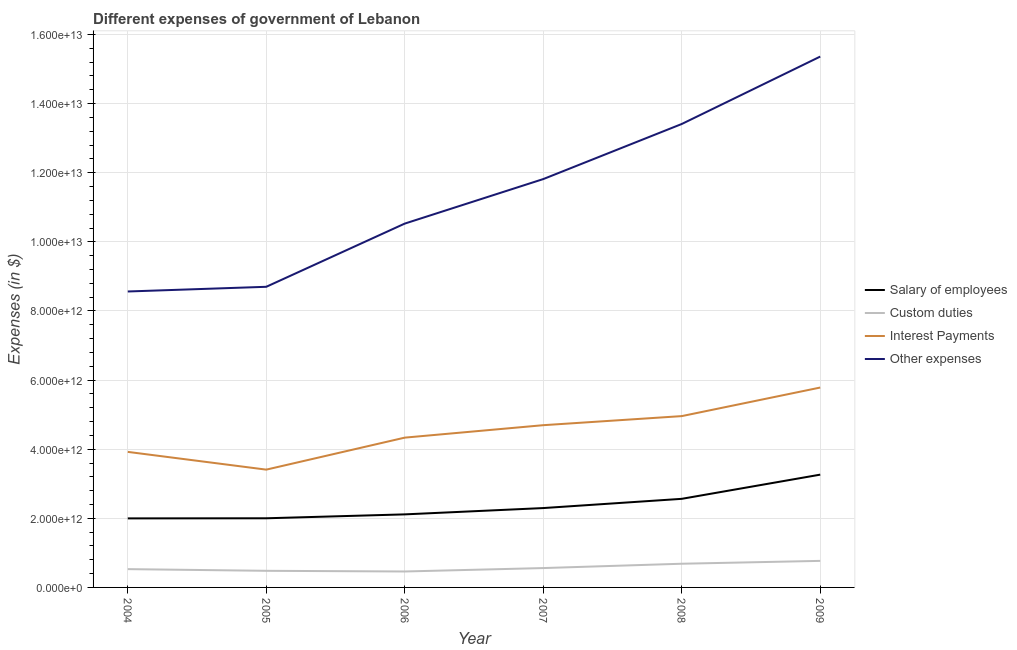Does the line corresponding to amount spent on interest payments intersect with the line corresponding to amount spent on custom duties?
Make the answer very short. No. Is the number of lines equal to the number of legend labels?
Your answer should be very brief. Yes. What is the amount spent on salary of employees in 2006?
Your answer should be very brief. 2.11e+12. Across all years, what is the maximum amount spent on custom duties?
Make the answer very short. 7.68e+11. Across all years, what is the minimum amount spent on custom duties?
Offer a very short reply. 4.61e+11. In which year was the amount spent on custom duties maximum?
Your answer should be compact. 2009. What is the total amount spent on interest payments in the graph?
Make the answer very short. 2.71e+13. What is the difference between the amount spent on custom duties in 2005 and that in 2009?
Offer a terse response. -2.87e+11. What is the difference between the amount spent on salary of employees in 2006 and the amount spent on other expenses in 2008?
Offer a terse response. -1.13e+13. What is the average amount spent on salary of employees per year?
Your answer should be very brief. 2.37e+12. In the year 2005, what is the difference between the amount spent on other expenses and amount spent on interest payments?
Make the answer very short. 5.29e+12. In how many years, is the amount spent on salary of employees greater than 14000000000000 $?
Your response must be concise. 0. What is the ratio of the amount spent on other expenses in 2005 to that in 2009?
Provide a succinct answer. 0.57. Is the difference between the amount spent on other expenses in 2007 and 2008 greater than the difference between the amount spent on interest payments in 2007 and 2008?
Your response must be concise. No. What is the difference between the highest and the second highest amount spent on other expenses?
Give a very brief answer. 1.95e+12. What is the difference between the highest and the lowest amount spent on other expenses?
Ensure brevity in your answer.  6.80e+12. Is the amount spent on salary of employees strictly greater than the amount spent on interest payments over the years?
Ensure brevity in your answer.  No. Is the amount spent on other expenses strictly less than the amount spent on salary of employees over the years?
Your answer should be compact. No. How many years are there in the graph?
Offer a terse response. 6. What is the difference between two consecutive major ticks on the Y-axis?
Make the answer very short. 2.00e+12. Does the graph contain any zero values?
Make the answer very short. No. Does the graph contain grids?
Ensure brevity in your answer.  Yes. Where does the legend appear in the graph?
Offer a very short reply. Center right. How are the legend labels stacked?
Your answer should be very brief. Vertical. What is the title of the graph?
Your answer should be compact. Different expenses of government of Lebanon. What is the label or title of the Y-axis?
Your answer should be very brief. Expenses (in $). What is the Expenses (in $) of Salary of employees in 2004?
Offer a very short reply. 2.00e+12. What is the Expenses (in $) in Custom duties in 2004?
Give a very brief answer. 5.30e+11. What is the Expenses (in $) of Interest Payments in 2004?
Your answer should be compact. 3.92e+12. What is the Expenses (in $) of Other expenses in 2004?
Make the answer very short. 8.56e+12. What is the Expenses (in $) in Salary of employees in 2005?
Offer a terse response. 2.00e+12. What is the Expenses (in $) of Custom duties in 2005?
Your response must be concise. 4.81e+11. What is the Expenses (in $) in Interest Payments in 2005?
Offer a very short reply. 3.41e+12. What is the Expenses (in $) in Other expenses in 2005?
Ensure brevity in your answer.  8.70e+12. What is the Expenses (in $) in Salary of employees in 2006?
Ensure brevity in your answer.  2.11e+12. What is the Expenses (in $) in Custom duties in 2006?
Keep it short and to the point. 4.61e+11. What is the Expenses (in $) of Interest Payments in 2006?
Your response must be concise. 4.33e+12. What is the Expenses (in $) of Other expenses in 2006?
Provide a short and direct response. 1.05e+13. What is the Expenses (in $) in Salary of employees in 2007?
Provide a succinct answer. 2.30e+12. What is the Expenses (in $) of Custom duties in 2007?
Your answer should be very brief. 5.61e+11. What is the Expenses (in $) in Interest Payments in 2007?
Provide a short and direct response. 4.69e+12. What is the Expenses (in $) of Other expenses in 2007?
Keep it short and to the point. 1.18e+13. What is the Expenses (in $) in Salary of employees in 2008?
Offer a very short reply. 2.56e+12. What is the Expenses (in $) of Custom duties in 2008?
Offer a very short reply. 6.86e+11. What is the Expenses (in $) of Interest Payments in 2008?
Ensure brevity in your answer.  4.96e+12. What is the Expenses (in $) in Other expenses in 2008?
Keep it short and to the point. 1.34e+13. What is the Expenses (in $) of Salary of employees in 2009?
Your answer should be compact. 3.26e+12. What is the Expenses (in $) of Custom duties in 2009?
Provide a succinct answer. 7.68e+11. What is the Expenses (in $) of Interest Payments in 2009?
Make the answer very short. 5.78e+12. What is the Expenses (in $) of Other expenses in 2009?
Ensure brevity in your answer.  1.54e+13. Across all years, what is the maximum Expenses (in $) in Salary of employees?
Keep it short and to the point. 3.26e+12. Across all years, what is the maximum Expenses (in $) of Custom duties?
Keep it short and to the point. 7.68e+11. Across all years, what is the maximum Expenses (in $) in Interest Payments?
Provide a succinct answer. 5.78e+12. Across all years, what is the maximum Expenses (in $) of Other expenses?
Give a very brief answer. 1.54e+13. Across all years, what is the minimum Expenses (in $) of Salary of employees?
Provide a succinct answer. 2.00e+12. Across all years, what is the minimum Expenses (in $) of Custom duties?
Provide a short and direct response. 4.61e+11. Across all years, what is the minimum Expenses (in $) in Interest Payments?
Keep it short and to the point. 3.41e+12. Across all years, what is the minimum Expenses (in $) of Other expenses?
Your answer should be very brief. 8.56e+12. What is the total Expenses (in $) of Salary of employees in the graph?
Your answer should be very brief. 1.42e+13. What is the total Expenses (in $) of Custom duties in the graph?
Offer a terse response. 3.49e+12. What is the total Expenses (in $) in Interest Payments in the graph?
Give a very brief answer. 2.71e+13. What is the total Expenses (in $) in Other expenses in the graph?
Your response must be concise. 6.84e+13. What is the difference between the Expenses (in $) of Salary of employees in 2004 and that in 2005?
Offer a very short reply. -3.43e+09. What is the difference between the Expenses (in $) in Custom duties in 2004 and that in 2005?
Your response must be concise. 4.86e+1. What is the difference between the Expenses (in $) of Interest Payments in 2004 and that in 2005?
Make the answer very short. 5.13e+11. What is the difference between the Expenses (in $) in Other expenses in 2004 and that in 2005?
Offer a terse response. -1.36e+11. What is the difference between the Expenses (in $) of Salary of employees in 2004 and that in 2006?
Provide a short and direct response. -1.16e+11. What is the difference between the Expenses (in $) of Custom duties in 2004 and that in 2006?
Ensure brevity in your answer.  6.85e+1. What is the difference between the Expenses (in $) in Interest Payments in 2004 and that in 2006?
Make the answer very short. -4.12e+11. What is the difference between the Expenses (in $) of Other expenses in 2004 and that in 2006?
Give a very brief answer. -1.96e+12. What is the difference between the Expenses (in $) in Salary of employees in 2004 and that in 2007?
Your answer should be very brief. -2.99e+11. What is the difference between the Expenses (in $) in Custom duties in 2004 and that in 2007?
Provide a succinct answer. -3.09e+1. What is the difference between the Expenses (in $) in Interest Payments in 2004 and that in 2007?
Provide a succinct answer. -7.72e+11. What is the difference between the Expenses (in $) in Other expenses in 2004 and that in 2007?
Ensure brevity in your answer.  -3.25e+12. What is the difference between the Expenses (in $) in Salary of employees in 2004 and that in 2008?
Your answer should be compact. -5.66e+11. What is the difference between the Expenses (in $) of Custom duties in 2004 and that in 2008?
Offer a very short reply. -1.56e+11. What is the difference between the Expenses (in $) of Interest Payments in 2004 and that in 2008?
Offer a terse response. -1.04e+12. What is the difference between the Expenses (in $) of Other expenses in 2004 and that in 2008?
Offer a very short reply. -4.85e+12. What is the difference between the Expenses (in $) in Salary of employees in 2004 and that in 2009?
Offer a very short reply. -1.27e+12. What is the difference between the Expenses (in $) of Custom duties in 2004 and that in 2009?
Ensure brevity in your answer.  -2.39e+11. What is the difference between the Expenses (in $) in Interest Payments in 2004 and that in 2009?
Provide a succinct answer. -1.86e+12. What is the difference between the Expenses (in $) of Other expenses in 2004 and that in 2009?
Your answer should be very brief. -6.80e+12. What is the difference between the Expenses (in $) of Salary of employees in 2005 and that in 2006?
Offer a terse response. -1.13e+11. What is the difference between the Expenses (in $) in Custom duties in 2005 and that in 2006?
Your answer should be compact. 1.98e+1. What is the difference between the Expenses (in $) in Interest Payments in 2005 and that in 2006?
Give a very brief answer. -9.26e+11. What is the difference between the Expenses (in $) of Other expenses in 2005 and that in 2006?
Offer a terse response. -1.83e+12. What is the difference between the Expenses (in $) in Salary of employees in 2005 and that in 2007?
Give a very brief answer. -2.96e+11. What is the difference between the Expenses (in $) in Custom duties in 2005 and that in 2007?
Your answer should be compact. -7.96e+1. What is the difference between the Expenses (in $) of Interest Payments in 2005 and that in 2007?
Provide a succinct answer. -1.29e+12. What is the difference between the Expenses (in $) in Other expenses in 2005 and that in 2007?
Offer a terse response. -3.12e+12. What is the difference between the Expenses (in $) in Salary of employees in 2005 and that in 2008?
Give a very brief answer. -5.63e+11. What is the difference between the Expenses (in $) in Custom duties in 2005 and that in 2008?
Your response must be concise. -2.05e+11. What is the difference between the Expenses (in $) in Interest Payments in 2005 and that in 2008?
Your answer should be compact. -1.55e+12. What is the difference between the Expenses (in $) of Other expenses in 2005 and that in 2008?
Your answer should be compact. -4.71e+12. What is the difference between the Expenses (in $) of Salary of employees in 2005 and that in 2009?
Provide a succinct answer. -1.26e+12. What is the difference between the Expenses (in $) in Custom duties in 2005 and that in 2009?
Give a very brief answer. -2.87e+11. What is the difference between the Expenses (in $) in Interest Payments in 2005 and that in 2009?
Provide a short and direct response. -2.38e+12. What is the difference between the Expenses (in $) in Other expenses in 2005 and that in 2009?
Your response must be concise. -6.66e+12. What is the difference between the Expenses (in $) of Salary of employees in 2006 and that in 2007?
Your response must be concise. -1.83e+11. What is the difference between the Expenses (in $) in Custom duties in 2006 and that in 2007?
Ensure brevity in your answer.  -9.94e+1. What is the difference between the Expenses (in $) in Interest Payments in 2006 and that in 2007?
Offer a very short reply. -3.60e+11. What is the difference between the Expenses (in $) in Other expenses in 2006 and that in 2007?
Offer a very short reply. -1.29e+12. What is the difference between the Expenses (in $) in Salary of employees in 2006 and that in 2008?
Your answer should be very brief. -4.50e+11. What is the difference between the Expenses (in $) in Custom duties in 2006 and that in 2008?
Offer a terse response. -2.25e+11. What is the difference between the Expenses (in $) in Interest Payments in 2006 and that in 2008?
Ensure brevity in your answer.  -6.23e+11. What is the difference between the Expenses (in $) of Other expenses in 2006 and that in 2008?
Give a very brief answer. -2.88e+12. What is the difference between the Expenses (in $) in Salary of employees in 2006 and that in 2009?
Your response must be concise. -1.15e+12. What is the difference between the Expenses (in $) of Custom duties in 2006 and that in 2009?
Keep it short and to the point. -3.07e+11. What is the difference between the Expenses (in $) in Interest Payments in 2006 and that in 2009?
Keep it short and to the point. -1.45e+12. What is the difference between the Expenses (in $) of Other expenses in 2006 and that in 2009?
Offer a very short reply. -4.83e+12. What is the difference between the Expenses (in $) in Salary of employees in 2007 and that in 2008?
Your response must be concise. -2.67e+11. What is the difference between the Expenses (in $) in Custom duties in 2007 and that in 2008?
Provide a short and direct response. -1.25e+11. What is the difference between the Expenses (in $) of Interest Payments in 2007 and that in 2008?
Ensure brevity in your answer.  -2.63e+11. What is the difference between the Expenses (in $) in Other expenses in 2007 and that in 2008?
Offer a terse response. -1.59e+12. What is the difference between the Expenses (in $) of Salary of employees in 2007 and that in 2009?
Keep it short and to the point. -9.67e+11. What is the difference between the Expenses (in $) of Custom duties in 2007 and that in 2009?
Give a very brief answer. -2.08e+11. What is the difference between the Expenses (in $) of Interest Payments in 2007 and that in 2009?
Give a very brief answer. -1.09e+12. What is the difference between the Expenses (in $) in Other expenses in 2007 and that in 2009?
Your response must be concise. -3.55e+12. What is the difference between the Expenses (in $) of Salary of employees in 2008 and that in 2009?
Provide a short and direct response. -7.00e+11. What is the difference between the Expenses (in $) of Custom duties in 2008 and that in 2009?
Give a very brief answer. -8.26e+1. What is the difference between the Expenses (in $) of Interest Payments in 2008 and that in 2009?
Ensure brevity in your answer.  -8.27e+11. What is the difference between the Expenses (in $) of Other expenses in 2008 and that in 2009?
Keep it short and to the point. -1.95e+12. What is the difference between the Expenses (in $) of Salary of employees in 2004 and the Expenses (in $) of Custom duties in 2005?
Provide a short and direct response. 1.52e+12. What is the difference between the Expenses (in $) in Salary of employees in 2004 and the Expenses (in $) in Interest Payments in 2005?
Ensure brevity in your answer.  -1.41e+12. What is the difference between the Expenses (in $) of Salary of employees in 2004 and the Expenses (in $) of Other expenses in 2005?
Offer a very short reply. -6.70e+12. What is the difference between the Expenses (in $) in Custom duties in 2004 and the Expenses (in $) in Interest Payments in 2005?
Make the answer very short. -2.88e+12. What is the difference between the Expenses (in $) in Custom duties in 2004 and the Expenses (in $) in Other expenses in 2005?
Your response must be concise. -8.17e+12. What is the difference between the Expenses (in $) of Interest Payments in 2004 and the Expenses (in $) of Other expenses in 2005?
Offer a very short reply. -4.78e+12. What is the difference between the Expenses (in $) in Salary of employees in 2004 and the Expenses (in $) in Custom duties in 2006?
Offer a terse response. 1.54e+12. What is the difference between the Expenses (in $) of Salary of employees in 2004 and the Expenses (in $) of Interest Payments in 2006?
Provide a succinct answer. -2.34e+12. What is the difference between the Expenses (in $) of Salary of employees in 2004 and the Expenses (in $) of Other expenses in 2006?
Keep it short and to the point. -8.53e+12. What is the difference between the Expenses (in $) of Custom duties in 2004 and the Expenses (in $) of Interest Payments in 2006?
Your answer should be very brief. -3.80e+12. What is the difference between the Expenses (in $) of Custom duties in 2004 and the Expenses (in $) of Other expenses in 2006?
Provide a short and direct response. -1.00e+13. What is the difference between the Expenses (in $) in Interest Payments in 2004 and the Expenses (in $) in Other expenses in 2006?
Your response must be concise. -6.61e+12. What is the difference between the Expenses (in $) in Salary of employees in 2004 and the Expenses (in $) in Custom duties in 2007?
Your answer should be compact. 1.44e+12. What is the difference between the Expenses (in $) of Salary of employees in 2004 and the Expenses (in $) of Interest Payments in 2007?
Provide a short and direct response. -2.70e+12. What is the difference between the Expenses (in $) in Salary of employees in 2004 and the Expenses (in $) in Other expenses in 2007?
Ensure brevity in your answer.  -9.82e+12. What is the difference between the Expenses (in $) of Custom duties in 2004 and the Expenses (in $) of Interest Payments in 2007?
Ensure brevity in your answer.  -4.16e+12. What is the difference between the Expenses (in $) of Custom duties in 2004 and the Expenses (in $) of Other expenses in 2007?
Your response must be concise. -1.13e+13. What is the difference between the Expenses (in $) of Interest Payments in 2004 and the Expenses (in $) of Other expenses in 2007?
Ensure brevity in your answer.  -7.89e+12. What is the difference between the Expenses (in $) of Salary of employees in 2004 and the Expenses (in $) of Custom duties in 2008?
Your response must be concise. 1.31e+12. What is the difference between the Expenses (in $) in Salary of employees in 2004 and the Expenses (in $) in Interest Payments in 2008?
Ensure brevity in your answer.  -2.96e+12. What is the difference between the Expenses (in $) in Salary of employees in 2004 and the Expenses (in $) in Other expenses in 2008?
Provide a short and direct response. -1.14e+13. What is the difference between the Expenses (in $) in Custom duties in 2004 and the Expenses (in $) in Interest Payments in 2008?
Provide a short and direct response. -4.43e+12. What is the difference between the Expenses (in $) of Custom duties in 2004 and the Expenses (in $) of Other expenses in 2008?
Your answer should be very brief. -1.29e+13. What is the difference between the Expenses (in $) of Interest Payments in 2004 and the Expenses (in $) of Other expenses in 2008?
Keep it short and to the point. -9.49e+12. What is the difference between the Expenses (in $) in Salary of employees in 2004 and the Expenses (in $) in Custom duties in 2009?
Your answer should be very brief. 1.23e+12. What is the difference between the Expenses (in $) of Salary of employees in 2004 and the Expenses (in $) of Interest Payments in 2009?
Your answer should be compact. -3.79e+12. What is the difference between the Expenses (in $) of Salary of employees in 2004 and the Expenses (in $) of Other expenses in 2009?
Offer a very short reply. -1.34e+13. What is the difference between the Expenses (in $) of Custom duties in 2004 and the Expenses (in $) of Interest Payments in 2009?
Offer a terse response. -5.25e+12. What is the difference between the Expenses (in $) of Custom duties in 2004 and the Expenses (in $) of Other expenses in 2009?
Your answer should be compact. -1.48e+13. What is the difference between the Expenses (in $) of Interest Payments in 2004 and the Expenses (in $) of Other expenses in 2009?
Your answer should be compact. -1.14e+13. What is the difference between the Expenses (in $) of Salary of employees in 2005 and the Expenses (in $) of Custom duties in 2006?
Your answer should be compact. 1.54e+12. What is the difference between the Expenses (in $) of Salary of employees in 2005 and the Expenses (in $) of Interest Payments in 2006?
Your answer should be very brief. -2.33e+12. What is the difference between the Expenses (in $) in Salary of employees in 2005 and the Expenses (in $) in Other expenses in 2006?
Offer a very short reply. -8.53e+12. What is the difference between the Expenses (in $) in Custom duties in 2005 and the Expenses (in $) in Interest Payments in 2006?
Provide a succinct answer. -3.85e+12. What is the difference between the Expenses (in $) in Custom duties in 2005 and the Expenses (in $) in Other expenses in 2006?
Your answer should be compact. -1.00e+13. What is the difference between the Expenses (in $) of Interest Payments in 2005 and the Expenses (in $) of Other expenses in 2006?
Provide a short and direct response. -7.12e+12. What is the difference between the Expenses (in $) in Salary of employees in 2005 and the Expenses (in $) in Custom duties in 2007?
Keep it short and to the point. 1.44e+12. What is the difference between the Expenses (in $) in Salary of employees in 2005 and the Expenses (in $) in Interest Payments in 2007?
Keep it short and to the point. -2.69e+12. What is the difference between the Expenses (in $) of Salary of employees in 2005 and the Expenses (in $) of Other expenses in 2007?
Make the answer very short. -9.82e+12. What is the difference between the Expenses (in $) in Custom duties in 2005 and the Expenses (in $) in Interest Payments in 2007?
Keep it short and to the point. -4.21e+12. What is the difference between the Expenses (in $) in Custom duties in 2005 and the Expenses (in $) in Other expenses in 2007?
Give a very brief answer. -1.13e+13. What is the difference between the Expenses (in $) of Interest Payments in 2005 and the Expenses (in $) of Other expenses in 2007?
Ensure brevity in your answer.  -8.41e+12. What is the difference between the Expenses (in $) in Salary of employees in 2005 and the Expenses (in $) in Custom duties in 2008?
Your response must be concise. 1.32e+12. What is the difference between the Expenses (in $) in Salary of employees in 2005 and the Expenses (in $) in Interest Payments in 2008?
Offer a very short reply. -2.96e+12. What is the difference between the Expenses (in $) of Salary of employees in 2005 and the Expenses (in $) of Other expenses in 2008?
Keep it short and to the point. -1.14e+13. What is the difference between the Expenses (in $) in Custom duties in 2005 and the Expenses (in $) in Interest Payments in 2008?
Ensure brevity in your answer.  -4.48e+12. What is the difference between the Expenses (in $) of Custom duties in 2005 and the Expenses (in $) of Other expenses in 2008?
Ensure brevity in your answer.  -1.29e+13. What is the difference between the Expenses (in $) in Interest Payments in 2005 and the Expenses (in $) in Other expenses in 2008?
Your response must be concise. -1.00e+13. What is the difference between the Expenses (in $) in Salary of employees in 2005 and the Expenses (in $) in Custom duties in 2009?
Your answer should be very brief. 1.23e+12. What is the difference between the Expenses (in $) of Salary of employees in 2005 and the Expenses (in $) of Interest Payments in 2009?
Make the answer very short. -3.78e+12. What is the difference between the Expenses (in $) in Salary of employees in 2005 and the Expenses (in $) in Other expenses in 2009?
Your answer should be very brief. -1.34e+13. What is the difference between the Expenses (in $) in Custom duties in 2005 and the Expenses (in $) in Interest Payments in 2009?
Keep it short and to the point. -5.30e+12. What is the difference between the Expenses (in $) in Custom duties in 2005 and the Expenses (in $) in Other expenses in 2009?
Keep it short and to the point. -1.49e+13. What is the difference between the Expenses (in $) of Interest Payments in 2005 and the Expenses (in $) of Other expenses in 2009?
Your answer should be very brief. -1.20e+13. What is the difference between the Expenses (in $) in Salary of employees in 2006 and the Expenses (in $) in Custom duties in 2007?
Offer a very short reply. 1.55e+12. What is the difference between the Expenses (in $) in Salary of employees in 2006 and the Expenses (in $) in Interest Payments in 2007?
Your answer should be compact. -2.58e+12. What is the difference between the Expenses (in $) of Salary of employees in 2006 and the Expenses (in $) of Other expenses in 2007?
Offer a very short reply. -9.70e+12. What is the difference between the Expenses (in $) of Custom duties in 2006 and the Expenses (in $) of Interest Payments in 2007?
Offer a terse response. -4.23e+12. What is the difference between the Expenses (in $) in Custom duties in 2006 and the Expenses (in $) in Other expenses in 2007?
Your answer should be very brief. -1.14e+13. What is the difference between the Expenses (in $) of Interest Payments in 2006 and the Expenses (in $) of Other expenses in 2007?
Provide a short and direct response. -7.48e+12. What is the difference between the Expenses (in $) of Salary of employees in 2006 and the Expenses (in $) of Custom duties in 2008?
Make the answer very short. 1.43e+12. What is the difference between the Expenses (in $) in Salary of employees in 2006 and the Expenses (in $) in Interest Payments in 2008?
Provide a succinct answer. -2.84e+12. What is the difference between the Expenses (in $) of Salary of employees in 2006 and the Expenses (in $) of Other expenses in 2008?
Offer a very short reply. -1.13e+13. What is the difference between the Expenses (in $) of Custom duties in 2006 and the Expenses (in $) of Interest Payments in 2008?
Provide a short and direct response. -4.50e+12. What is the difference between the Expenses (in $) in Custom duties in 2006 and the Expenses (in $) in Other expenses in 2008?
Your response must be concise. -1.29e+13. What is the difference between the Expenses (in $) in Interest Payments in 2006 and the Expenses (in $) in Other expenses in 2008?
Your answer should be very brief. -9.08e+12. What is the difference between the Expenses (in $) in Salary of employees in 2006 and the Expenses (in $) in Custom duties in 2009?
Offer a very short reply. 1.35e+12. What is the difference between the Expenses (in $) in Salary of employees in 2006 and the Expenses (in $) in Interest Payments in 2009?
Your answer should be very brief. -3.67e+12. What is the difference between the Expenses (in $) of Salary of employees in 2006 and the Expenses (in $) of Other expenses in 2009?
Your answer should be very brief. -1.32e+13. What is the difference between the Expenses (in $) in Custom duties in 2006 and the Expenses (in $) in Interest Payments in 2009?
Keep it short and to the point. -5.32e+12. What is the difference between the Expenses (in $) in Custom duties in 2006 and the Expenses (in $) in Other expenses in 2009?
Offer a terse response. -1.49e+13. What is the difference between the Expenses (in $) of Interest Payments in 2006 and the Expenses (in $) of Other expenses in 2009?
Your answer should be very brief. -1.10e+13. What is the difference between the Expenses (in $) of Salary of employees in 2007 and the Expenses (in $) of Custom duties in 2008?
Your response must be concise. 1.61e+12. What is the difference between the Expenses (in $) of Salary of employees in 2007 and the Expenses (in $) of Interest Payments in 2008?
Keep it short and to the point. -2.66e+12. What is the difference between the Expenses (in $) in Salary of employees in 2007 and the Expenses (in $) in Other expenses in 2008?
Ensure brevity in your answer.  -1.11e+13. What is the difference between the Expenses (in $) of Custom duties in 2007 and the Expenses (in $) of Interest Payments in 2008?
Provide a succinct answer. -4.40e+12. What is the difference between the Expenses (in $) of Custom duties in 2007 and the Expenses (in $) of Other expenses in 2008?
Offer a terse response. -1.28e+13. What is the difference between the Expenses (in $) in Interest Payments in 2007 and the Expenses (in $) in Other expenses in 2008?
Keep it short and to the point. -8.72e+12. What is the difference between the Expenses (in $) in Salary of employees in 2007 and the Expenses (in $) in Custom duties in 2009?
Offer a terse response. 1.53e+12. What is the difference between the Expenses (in $) of Salary of employees in 2007 and the Expenses (in $) of Interest Payments in 2009?
Provide a succinct answer. -3.49e+12. What is the difference between the Expenses (in $) in Salary of employees in 2007 and the Expenses (in $) in Other expenses in 2009?
Provide a succinct answer. -1.31e+13. What is the difference between the Expenses (in $) in Custom duties in 2007 and the Expenses (in $) in Interest Payments in 2009?
Offer a very short reply. -5.22e+12. What is the difference between the Expenses (in $) in Custom duties in 2007 and the Expenses (in $) in Other expenses in 2009?
Your answer should be very brief. -1.48e+13. What is the difference between the Expenses (in $) of Interest Payments in 2007 and the Expenses (in $) of Other expenses in 2009?
Provide a short and direct response. -1.07e+13. What is the difference between the Expenses (in $) of Salary of employees in 2008 and the Expenses (in $) of Custom duties in 2009?
Your answer should be compact. 1.80e+12. What is the difference between the Expenses (in $) of Salary of employees in 2008 and the Expenses (in $) of Interest Payments in 2009?
Your answer should be very brief. -3.22e+12. What is the difference between the Expenses (in $) in Salary of employees in 2008 and the Expenses (in $) in Other expenses in 2009?
Your answer should be very brief. -1.28e+13. What is the difference between the Expenses (in $) of Custom duties in 2008 and the Expenses (in $) of Interest Payments in 2009?
Provide a succinct answer. -5.10e+12. What is the difference between the Expenses (in $) in Custom duties in 2008 and the Expenses (in $) in Other expenses in 2009?
Provide a short and direct response. -1.47e+13. What is the difference between the Expenses (in $) in Interest Payments in 2008 and the Expenses (in $) in Other expenses in 2009?
Offer a terse response. -1.04e+13. What is the average Expenses (in $) in Salary of employees per year?
Your response must be concise. 2.37e+12. What is the average Expenses (in $) in Custom duties per year?
Your answer should be compact. 5.81e+11. What is the average Expenses (in $) in Interest Payments per year?
Keep it short and to the point. 4.52e+12. What is the average Expenses (in $) in Other expenses per year?
Offer a very short reply. 1.14e+13. In the year 2004, what is the difference between the Expenses (in $) of Salary of employees and Expenses (in $) of Custom duties?
Your answer should be compact. 1.47e+12. In the year 2004, what is the difference between the Expenses (in $) of Salary of employees and Expenses (in $) of Interest Payments?
Provide a short and direct response. -1.92e+12. In the year 2004, what is the difference between the Expenses (in $) of Salary of employees and Expenses (in $) of Other expenses?
Your answer should be compact. -6.57e+12. In the year 2004, what is the difference between the Expenses (in $) of Custom duties and Expenses (in $) of Interest Payments?
Your answer should be very brief. -3.39e+12. In the year 2004, what is the difference between the Expenses (in $) of Custom duties and Expenses (in $) of Other expenses?
Offer a terse response. -8.03e+12. In the year 2004, what is the difference between the Expenses (in $) in Interest Payments and Expenses (in $) in Other expenses?
Offer a terse response. -4.64e+12. In the year 2005, what is the difference between the Expenses (in $) of Salary of employees and Expenses (in $) of Custom duties?
Make the answer very short. 1.52e+12. In the year 2005, what is the difference between the Expenses (in $) of Salary of employees and Expenses (in $) of Interest Payments?
Ensure brevity in your answer.  -1.41e+12. In the year 2005, what is the difference between the Expenses (in $) in Salary of employees and Expenses (in $) in Other expenses?
Keep it short and to the point. -6.70e+12. In the year 2005, what is the difference between the Expenses (in $) of Custom duties and Expenses (in $) of Interest Payments?
Provide a short and direct response. -2.93e+12. In the year 2005, what is the difference between the Expenses (in $) in Custom duties and Expenses (in $) in Other expenses?
Ensure brevity in your answer.  -8.22e+12. In the year 2005, what is the difference between the Expenses (in $) in Interest Payments and Expenses (in $) in Other expenses?
Keep it short and to the point. -5.29e+12. In the year 2006, what is the difference between the Expenses (in $) of Salary of employees and Expenses (in $) of Custom duties?
Keep it short and to the point. 1.65e+12. In the year 2006, what is the difference between the Expenses (in $) of Salary of employees and Expenses (in $) of Interest Payments?
Your answer should be compact. -2.22e+12. In the year 2006, what is the difference between the Expenses (in $) in Salary of employees and Expenses (in $) in Other expenses?
Provide a succinct answer. -8.41e+12. In the year 2006, what is the difference between the Expenses (in $) in Custom duties and Expenses (in $) in Interest Payments?
Provide a succinct answer. -3.87e+12. In the year 2006, what is the difference between the Expenses (in $) in Custom duties and Expenses (in $) in Other expenses?
Provide a short and direct response. -1.01e+13. In the year 2006, what is the difference between the Expenses (in $) in Interest Payments and Expenses (in $) in Other expenses?
Make the answer very short. -6.19e+12. In the year 2007, what is the difference between the Expenses (in $) in Salary of employees and Expenses (in $) in Custom duties?
Make the answer very short. 1.74e+12. In the year 2007, what is the difference between the Expenses (in $) in Salary of employees and Expenses (in $) in Interest Payments?
Provide a succinct answer. -2.40e+12. In the year 2007, what is the difference between the Expenses (in $) of Salary of employees and Expenses (in $) of Other expenses?
Your answer should be compact. -9.52e+12. In the year 2007, what is the difference between the Expenses (in $) in Custom duties and Expenses (in $) in Interest Payments?
Give a very brief answer. -4.13e+12. In the year 2007, what is the difference between the Expenses (in $) of Custom duties and Expenses (in $) of Other expenses?
Offer a very short reply. -1.13e+13. In the year 2007, what is the difference between the Expenses (in $) in Interest Payments and Expenses (in $) in Other expenses?
Offer a terse response. -7.12e+12. In the year 2008, what is the difference between the Expenses (in $) of Salary of employees and Expenses (in $) of Custom duties?
Your answer should be compact. 1.88e+12. In the year 2008, what is the difference between the Expenses (in $) in Salary of employees and Expenses (in $) in Interest Payments?
Ensure brevity in your answer.  -2.39e+12. In the year 2008, what is the difference between the Expenses (in $) in Salary of employees and Expenses (in $) in Other expenses?
Keep it short and to the point. -1.08e+13. In the year 2008, what is the difference between the Expenses (in $) in Custom duties and Expenses (in $) in Interest Payments?
Offer a terse response. -4.27e+12. In the year 2008, what is the difference between the Expenses (in $) of Custom duties and Expenses (in $) of Other expenses?
Your answer should be compact. -1.27e+13. In the year 2008, what is the difference between the Expenses (in $) in Interest Payments and Expenses (in $) in Other expenses?
Offer a very short reply. -8.45e+12. In the year 2009, what is the difference between the Expenses (in $) in Salary of employees and Expenses (in $) in Custom duties?
Keep it short and to the point. 2.50e+12. In the year 2009, what is the difference between the Expenses (in $) in Salary of employees and Expenses (in $) in Interest Payments?
Provide a short and direct response. -2.52e+12. In the year 2009, what is the difference between the Expenses (in $) of Salary of employees and Expenses (in $) of Other expenses?
Your response must be concise. -1.21e+13. In the year 2009, what is the difference between the Expenses (in $) of Custom duties and Expenses (in $) of Interest Payments?
Your answer should be compact. -5.02e+12. In the year 2009, what is the difference between the Expenses (in $) of Custom duties and Expenses (in $) of Other expenses?
Offer a very short reply. -1.46e+13. In the year 2009, what is the difference between the Expenses (in $) in Interest Payments and Expenses (in $) in Other expenses?
Your response must be concise. -9.58e+12. What is the ratio of the Expenses (in $) of Salary of employees in 2004 to that in 2005?
Provide a succinct answer. 1. What is the ratio of the Expenses (in $) in Custom duties in 2004 to that in 2005?
Make the answer very short. 1.1. What is the ratio of the Expenses (in $) of Interest Payments in 2004 to that in 2005?
Offer a very short reply. 1.15. What is the ratio of the Expenses (in $) of Other expenses in 2004 to that in 2005?
Your answer should be compact. 0.98. What is the ratio of the Expenses (in $) of Salary of employees in 2004 to that in 2006?
Keep it short and to the point. 0.94. What is the ratio of the Expenses (in $) in Custom duties in 2004 to that in 2006?
Make the answer very short. 1.15. What is the ratio of the Expenses (in $) of Interest Payments in 2004 to that in 2006?
Keep it short and to the point. 0.9. What is the ratio of the Expenses (in $) in Other expenses in 2004 to that in 2006?
Provide a short and direct response. 0.81. What is the ratio of the Expenses (in $) of Salary of employees in 2004 to that in 2007?
Offer a very short reply. 0.87. What is the ratio of the Expenses (in $) of Custom duties in 2004 to that in 2007?
Offer a terse response. 0.94. What is the ratio of the Expenses (in $) of Interest Payments in 2004 to that in 2007?
Offer a very short reply. 0.84. What is the ratio of the Expenses (in $) in Other expenses in 2004 to that in 2007?
Offer a terse response. 0.72. What is the ratio of the Expenses (in $) in Salary of employees in 2004 to that in 2008?
Provide a succinct answer. 0.78. What is the ratio of the Expenses (in $) in Custom duties in 2004 to that in 2008?
Keep it short and to the point. 0.77. What is the ratio of the Expenses (in $) in Interest Payments in 2004 to that in 2008?
Provide a short and direct response. 0.79. What is the ratio of the Expenses (in $) in Other expenses in 2004 to that in 2008?
Keep it short and to the point. 0.64. What is the ratio of the Expenses (in $) in Salary of employees in 2004 to that in 2009?
Your response must be concise. 0.61. What is the ratio of the Expenses (in $) in Custom duties in 2004 to that in 2009?
Offer a very short reply. 0.69. What is the ratio of the Expenses (in $) in Interest Payments in 2004 to that in 2009?
Give a very brief answer. 0.68. What is the ratio of the Expenses (in $) in Other expenses in 2004 to that in 2009?
Ensure brevity in your answer.  0.56. What is the ratio of the Expenses (in $) in Salary of employees in 2005 to that in 2006?
Your answer should be compact. 0.95. What is the ratio of the Expenses (in $) of Custom duties in 2005 to that in 2006?
Give a very brief answer. 1.04. What is the ratio of the Expenses (in $) in Interest Payments in 2005 to that in 2006?
Your answer should be very brief. 0.79. What is the ratio of the Expenses (in $) of Other expenses in 2005 to that in 2006?
Provide a short and direct response. 0.83. What is the ratio of the Expenses (in $) of Salary of employees in 2005 to that in 2007?
Keep it short and to the point. 0.87. What is the ratio of the Expenses (in $) in Custom duties in 2005 to that in 2007?
Your response must be concise. 0.86. What is the ratio of the Expenses (in $) in Interest Payments in 2005 to that in 2007?
Your response must be concise. 0.73. What is the ratio of the Expenses (in $) in Other expenses in 2005 to that in 2007?
Ensure brevity in your answer.  0.74. What is the ratio of the Expenses (in $) of Salary of employees in 2005 to that in 2008?
Offer a very short reply. 0.78. What is the ratio of the Expenses (in $) in Custom duties in 2005 to that in 2008?
Your answer should be compact. 0.7. What is the ratio of the Expenses (in $) in Interest Payments in 2005 to that in 2008?
Offer a terse response. 0.69. What is the ratio of the Expenses (in $) of Other expenses in 2005 to that in 2008?
Give a very brief answer. 0.65. What is the ratio of the Expenses (in $) in Salary of employees in 2005 to that in 2009?
Your response must be concise. 0.61. What is the ratio of the Expenses (in $) of Custom duties in 2005 to that in 2009?
Keep it short and to the point. 0.63. What is the ratio of the Expenses (in $) in Interest Payments in 2005 to that in 2009?
Your answer should be compact. 0.59. What is the ratio of the Expenses (in $) of Other expenses in 2005 to that in 2009?
Give a very brief answer. 0.57. What is the ratio of the Expenses (in $) in Salary of employees in 2006 to that in 2007?
Offer a very short reply. 0.92. What is the ratio of the Expenses (in $) in Custom duties in 2006 to that in 2007?
Provide a succinct answer. 0.82. What is the ratio of the Expenses (in $) in Interest Payments in 2006 to that in 2007?
Make the answer very short. 0.92. What is the ratio of the Expenses (in $) in Other expenses in 2006 to that in 2007?
Offer a very short reply. 0.89. What is the ratio of the Expenses (in $) in Salary of employees in 2006 to that in 2008?
Make the answer very short. 0.82. What is the ratio of the Expenses (in $) in Custom duties in 2006 to that in 2008?
Keep it short and to the point. 0.67. What is the ratio of the Expenses (in $) of Interest Payments in 2006 to that in 2008?
Offer a very short reply. 0.87. What is the ratio of the Expenses (in $) of Other expenses in 2006 to that in 2008?
Provide a short and direct response. 0.79. What is the ratio of the Expenses (in $) in Salary of employees in 2006 to that in 2009?
Make the answer very short. 0.65. What is the ratio of the Expenses (in $) of Custom duties in 2006 to that in 2009?
Make the answer very short. 0.6. What is the ratio of the Expenses (in $) of Interest Payments in 2006 to that in 2009?
Offer a very short reply. 0.75. What is the ratio of the Expenses (in $) of Other expenses in 2006 to that in 2009?
Your answer should be very brief. 0.69. What is the ratio of the Expenses (in $) in Salary of employees in 2007 to that in 2008?
Offer a terse response. 0.9. What is the ratio of the Expenses (in $) of Custom duties in 2007 to that in 2008?
Your response must be concise. 0.82. What is the ratio of the Expenses (in $) of Interest Payments in 2007 to that in 2008?
Offer a very short reply. 0.95. What is the ratio of the Expenses (in $) of Other expenses in 2007 to that in 2008?
Your answer should be very brief. 0.88. What is the ratio of the Expenses (in $) of Salary of employees in 2007 to that in 2009?
Your answer should be compact. 0.7. What is the ratio of the Expenses (in $) in Custom duties in 2007 to that in 2009?
Your response must be concise. 0.73. What is the ratio of the Expenses (in $) in Interest Payments in 2007 to that in 2009?
Provide a short and direct response. 0.81. What is the ratio of the Expenses (in $) of Other expenses in 2007 to that in 2009?
Offer a very short reply. 0.77. What is the ratio of the Expenses (in $) in Salary of employees in 2008 to that in 2009?
Offer a terse response. 0.79. What is the ratio of the Expenses (in $) of Custom duties in 2008 to that in 2009?
Offer a terse response. 0.89. What is the ratio of the Expenses (in $) in Interest Payments in 2008 to that in 2009?
Your answer should be compact. 0.86. What is the ratio of the Expenses (in $) of Other expenses in 2008 to that in 2009?
Offer a terse response. 0.87. What is the difference between the highest and the second highest Expenses (in $) in Salary of employees?
Offer a terse response. 7.00e+11. What is the difference between the highest and the second highest Expenses (in $) of Custom duties?
Ensure brevity in your answer.  8.26e+1. What is the difference between the highest and the second highest Expenses (in $) in Interest Payments?
Your answer should be compact. 8.27e+11. What is the difference between the highest and the second highest Expenses (in $) in Other expenses?
Keep it short and to the point. 1.95e+12. What is the difference between the highest and the lowest Expenses (in $) in Salary of employees?
Keep it short and to the point. 1.27e+12. What is the difference between the highest and the lowest Expenses (in $) of Custom duties?
Offer a very short reply. 3.07e+11. What is the difference between the highest and the lowest Expenses (in $) of Interest Payments?
Your answer should be very brief. 2.38e+12. What is the difference between the highest and the lowest Expenses (in $) in Other expenses?
Offer a very short reply. 6.80e+12. 